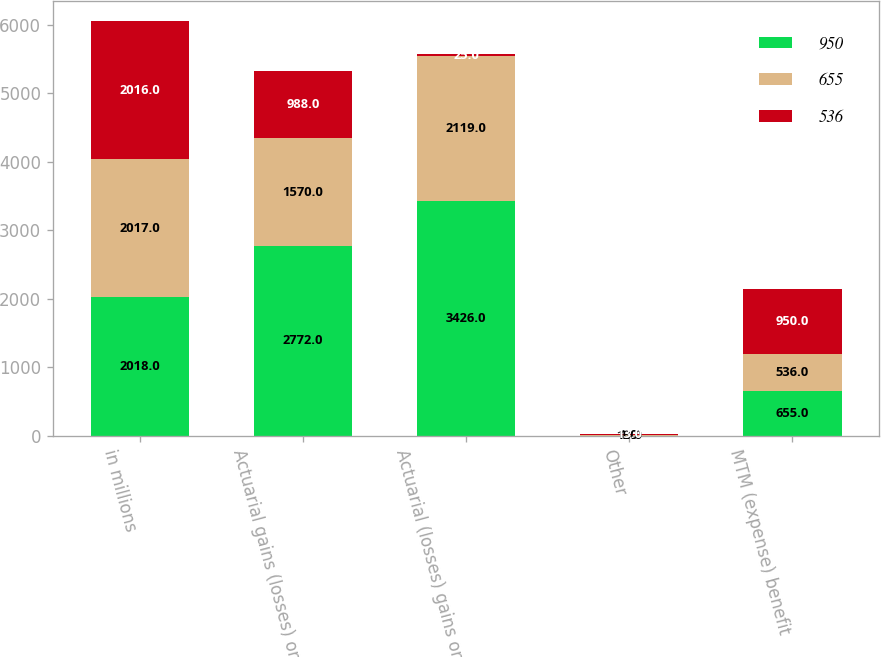Convert chart to OTSL. <chart><loc_0><loc_0><loc_500><loc_500><stacked_bar_chart><ecel><fcel>in millions<fcel>Actuarial gains (losses) on<fcel>Actuarial (losses) gains on<fcel>Other<fcel>MTM (expense) benefit<nl><fcel>950<fcel>2018<fcel>2772<fcel>3426<fcel>1<fcel>655<nl><fcel>655<fcel>2017<fcel>1570<fcel>2119<fcel>13<fcel>536<nl><fcel>536<fcel>2016<fcel>988<fcel>25<fcel>13<fcel>950<nl></chart> 